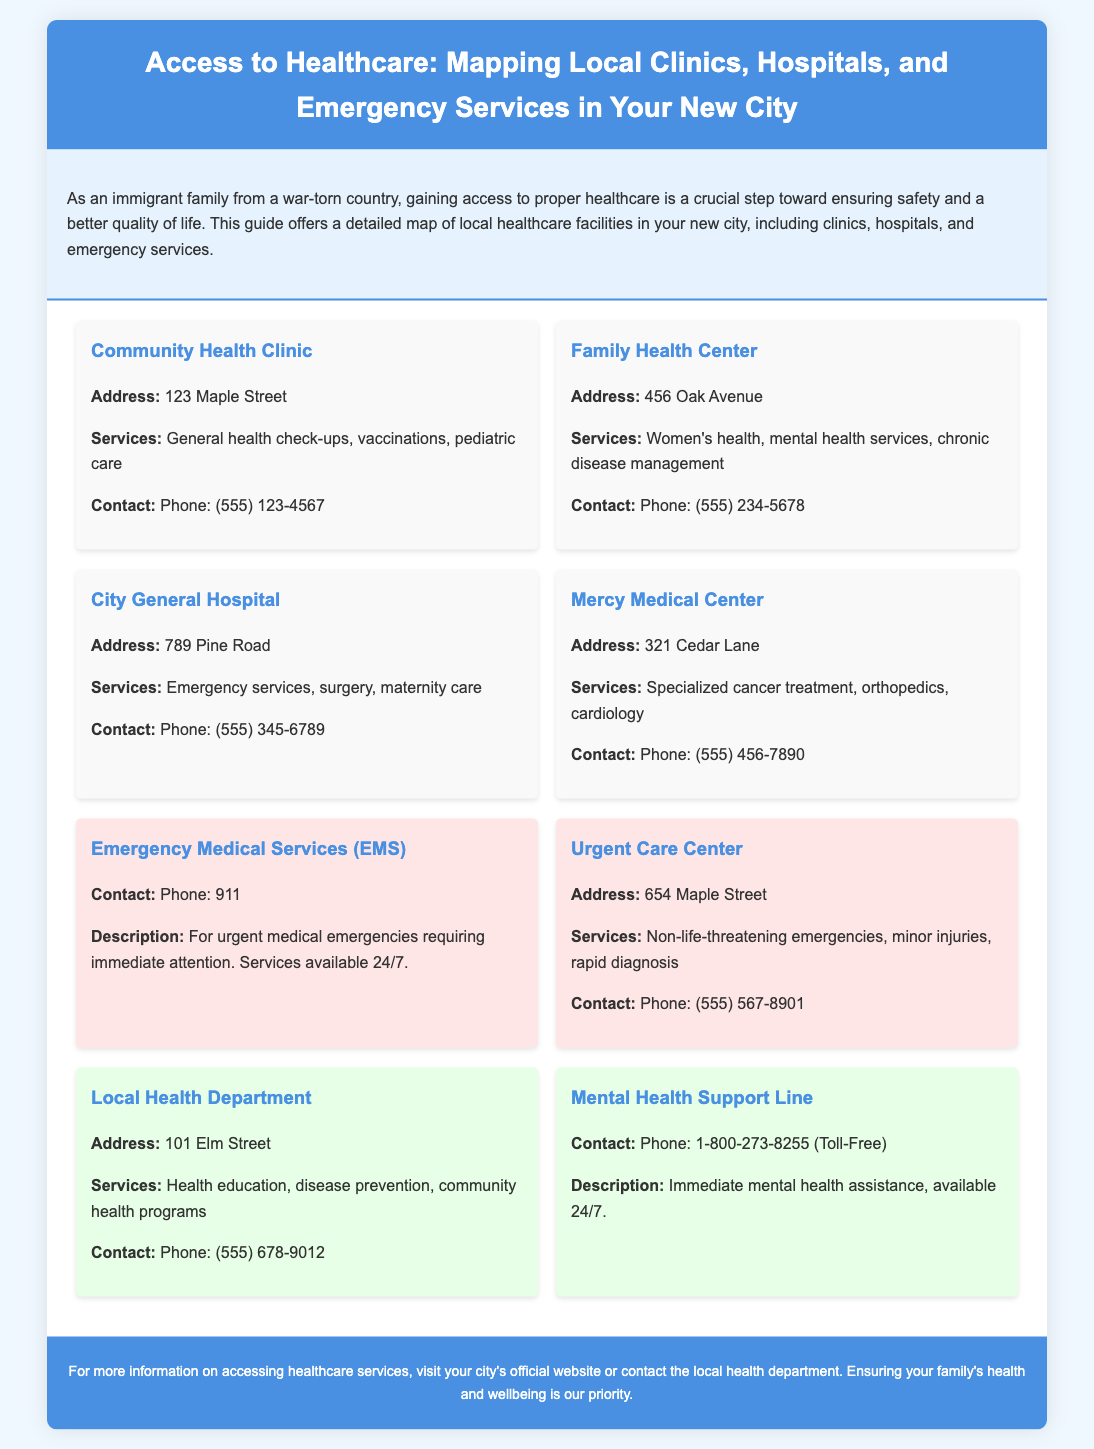what is the address of the Community Health Clinic? The address is specifically mentioned under the Community Health Clinic section in the document.
Answer: 123 Maple Street what services does the Family Health Center provide? The services are listed directly under the Family Health Center information.
Answer: Women's health, mental health services, chronic disease management what is the contact number for City General Hospital? The contact number is displayed right under the City General Hospital's name in the document.
Answer: (555) 345-6789 which location provides emergency medical services? The section specifically indicates the Emergency Medical Services (EMS) for urgent medical needs.
Answer: Emergency Medical Services (EMS) how many local clinics are listed in the document? The document lists several health facilities, allowing for a count.
Answer: 7 what number should you call for immediate mental health assistance? The document explicitly states the contact number for mental health support.
Answer: 1-800-273-8255 which hospital specializes in cancer treatment? The document details services provided by different hospitals, including specialization information.
Answer: Mercy Medical Center what type of services does the Urgent Care Center offer? The services for the Urgent Care Center are mentioned in its section.
Answer: Non-life-threatening emergencies, minor injuries, rapid diagnosis 